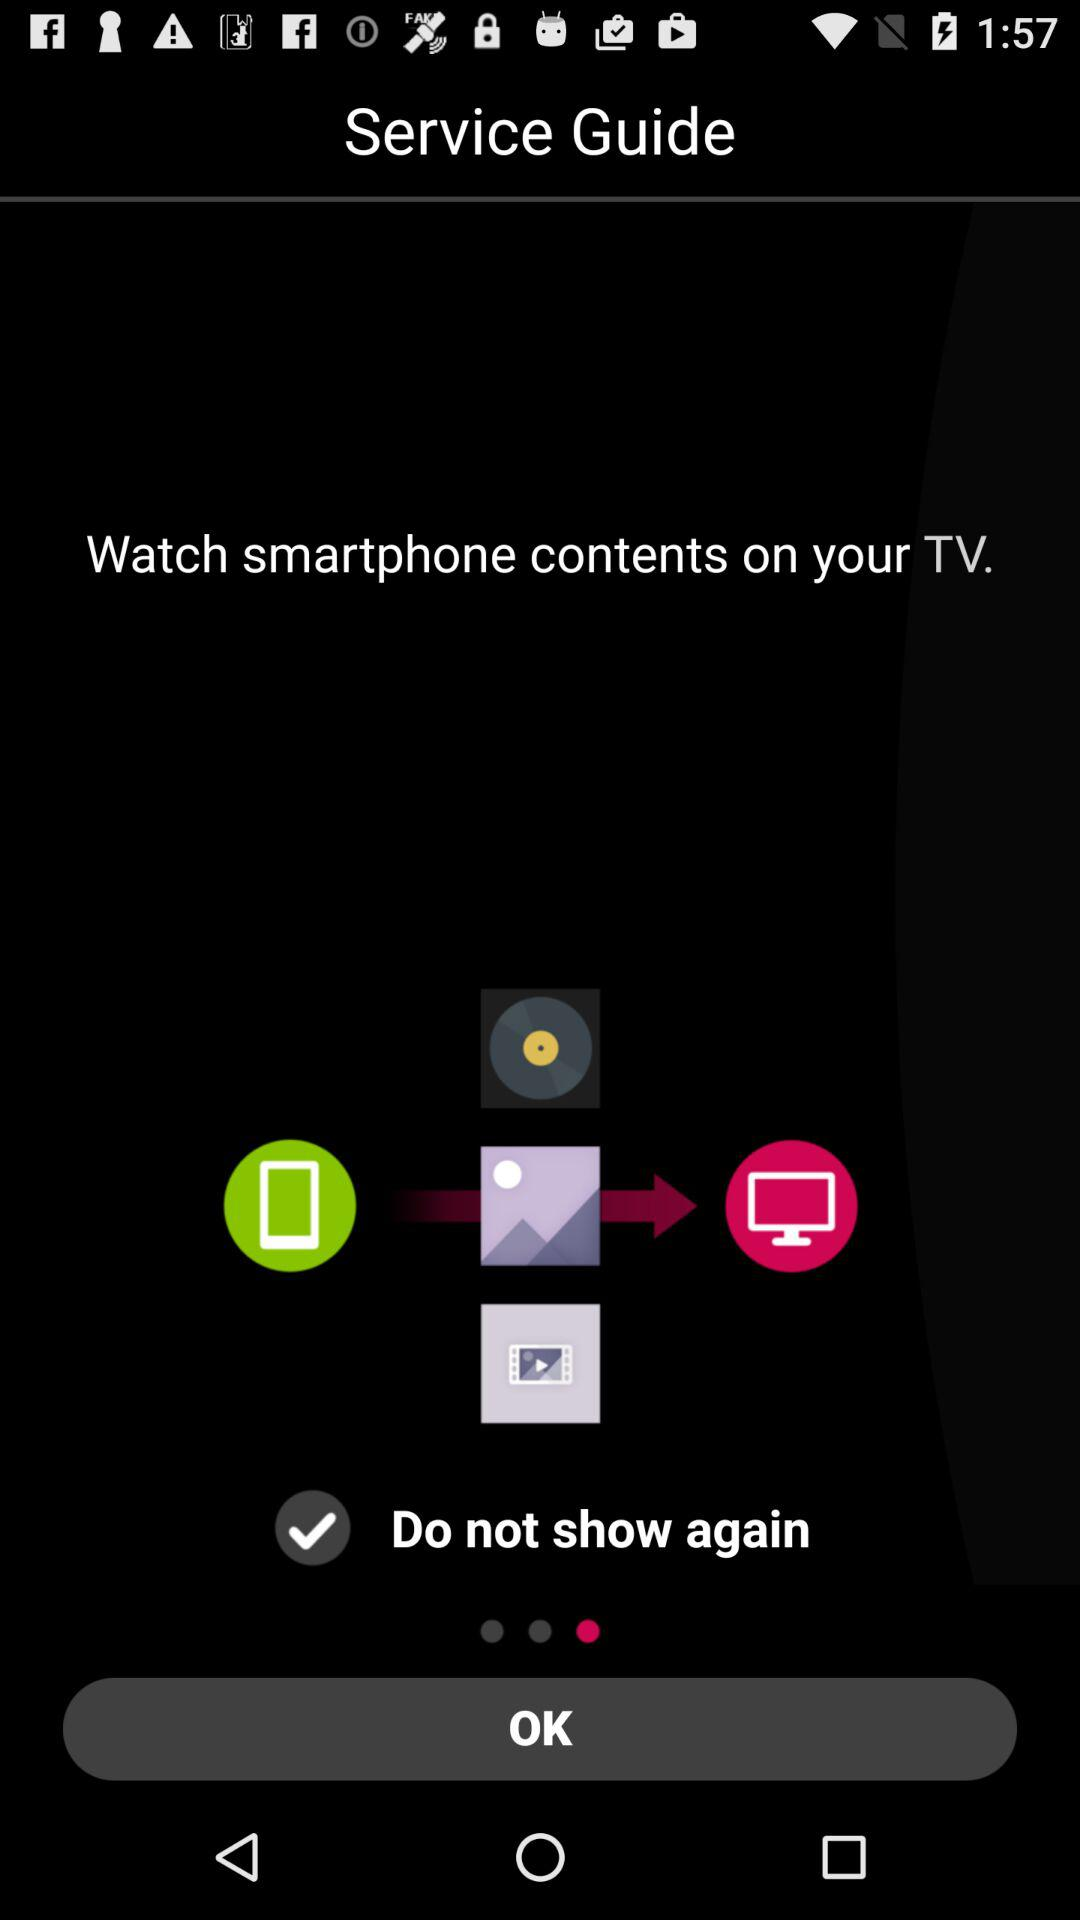What is the status of "Do not show again"? The status of "Do not show again" is "on". 